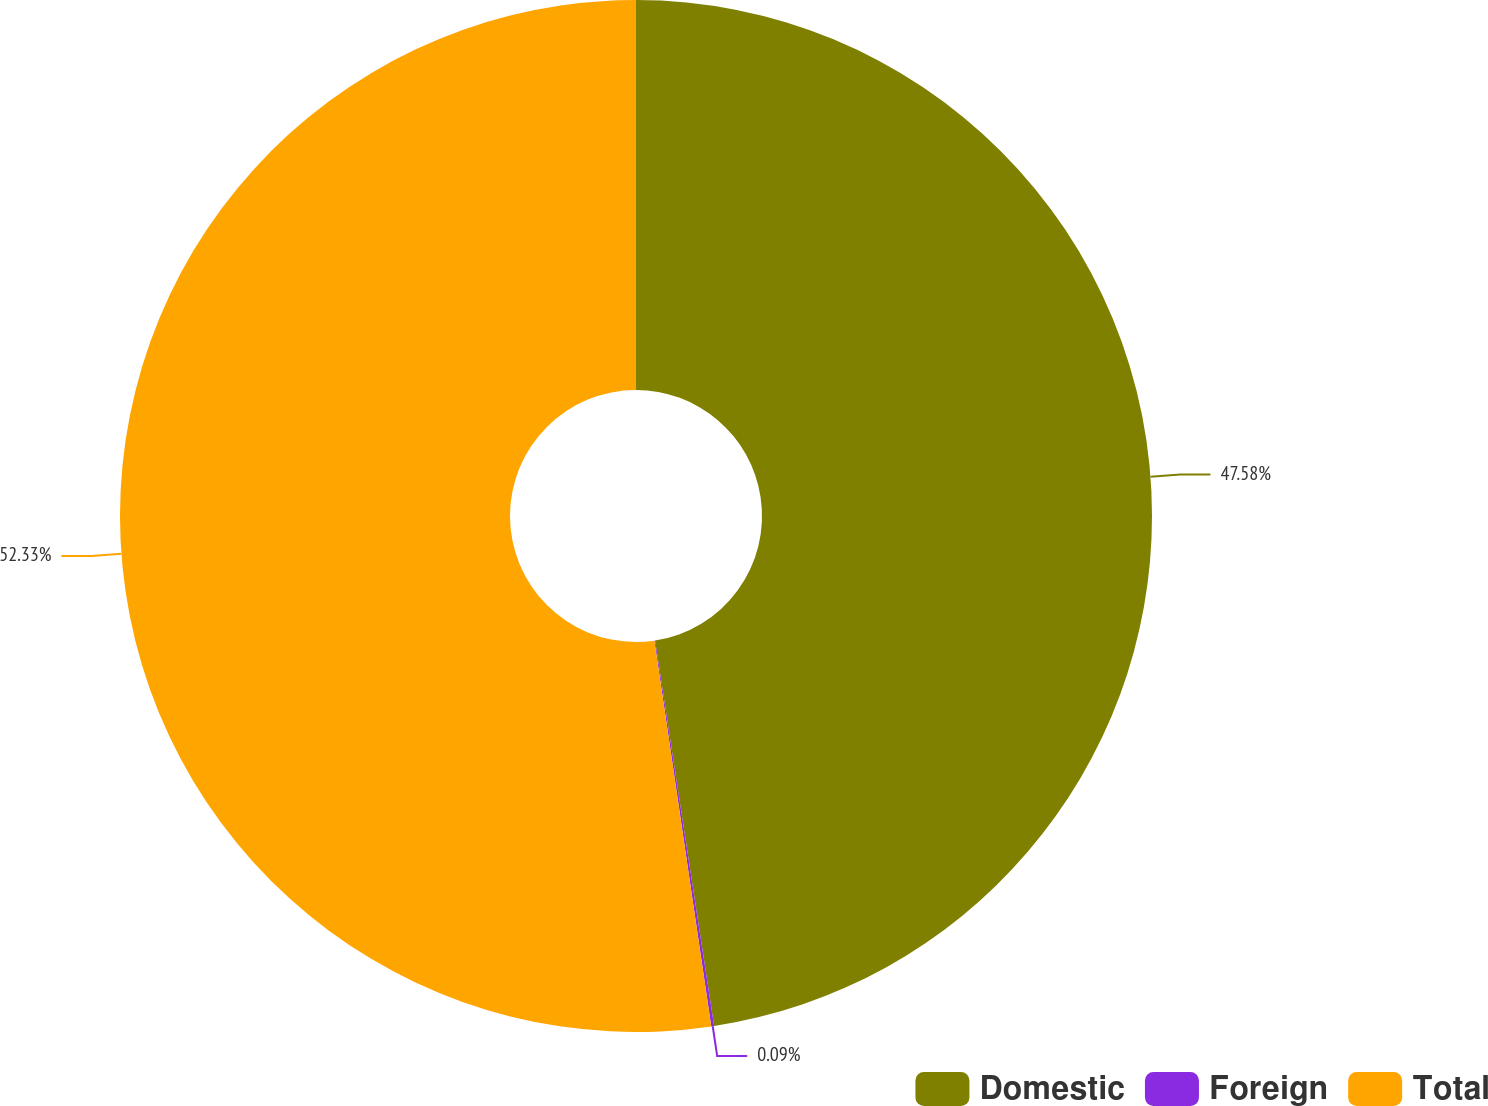Convert chart. <chart><loc_0><loc_0><loc_500><loc_500><pie_chart><fcel>Domestic<fcel>Foreign<fcel>Total<nl><fcel>47.58%<fcel>0.09%<fcel>52.33%<nl></chart> 